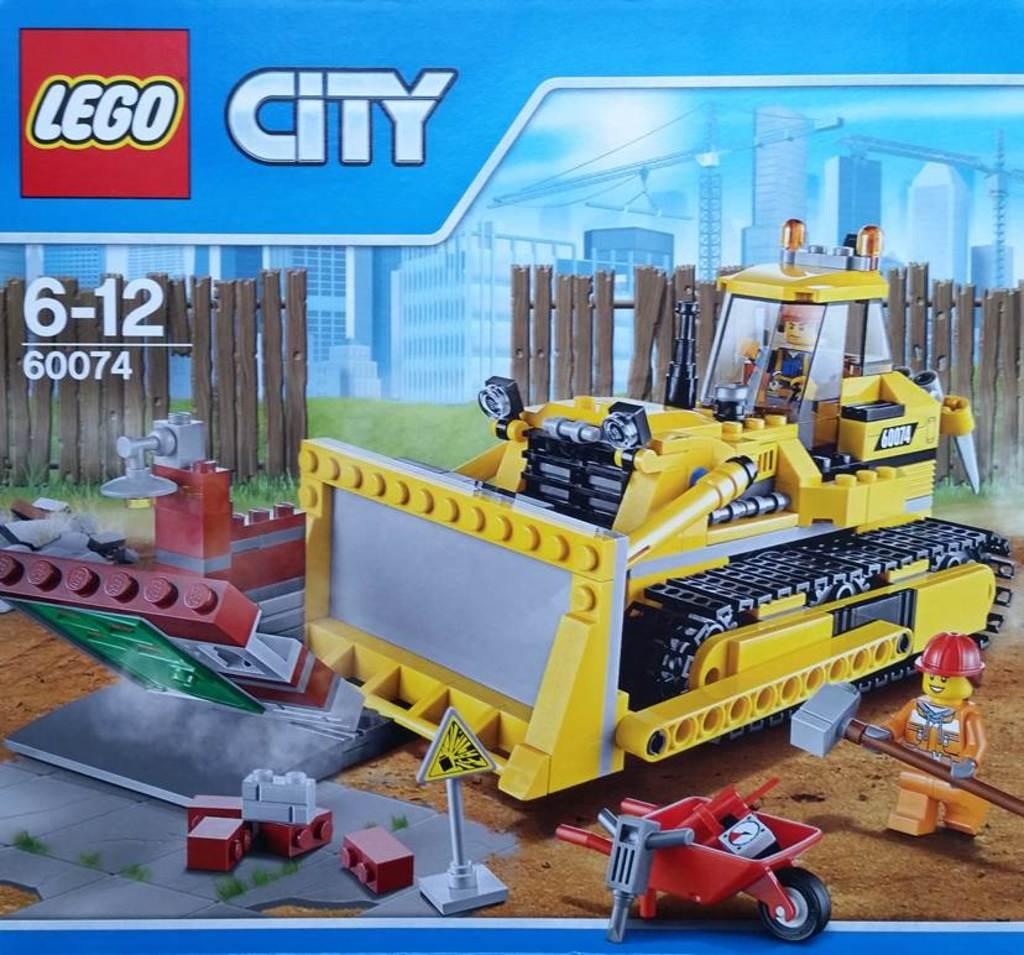What is the main subject of the image? The main subject of the image is a picture of a craft build. What material is used to create the craft build? The craft is made with legos. What is the size of the steel plough in the image? There is no steel plough present in the image. 